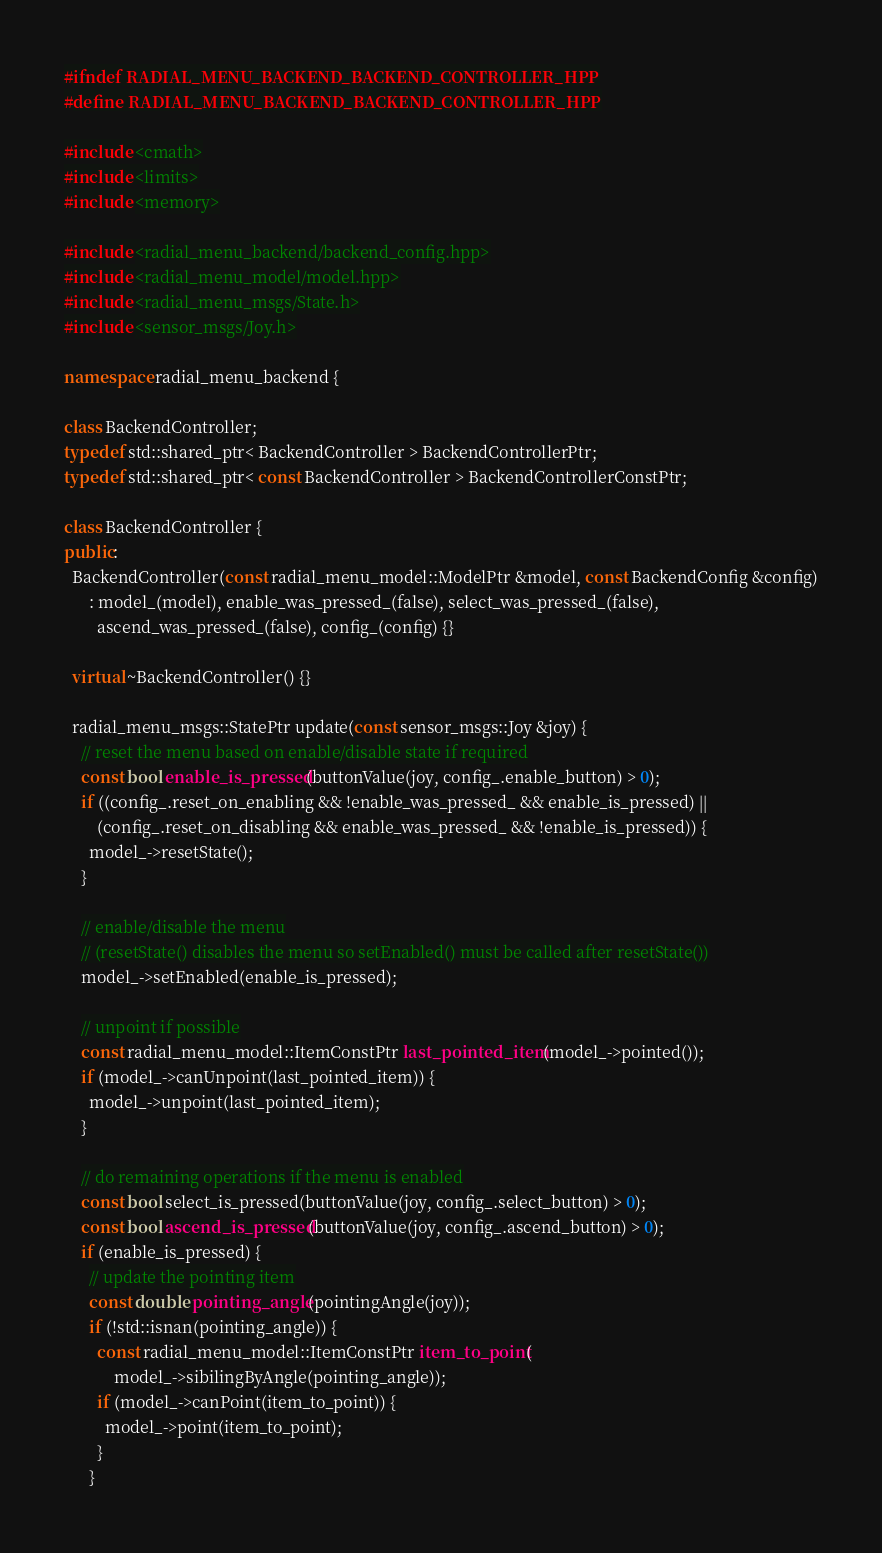Convert code to text. <code><loc_0><loc_0><loc_500><loc_500><_C++_>#ifndef RADIAL_MENU_BACKEND_BACKEND_CONTROLLER_HPP
#define RADIAL_MENU_BACKEND_BACKEND_CONTROLLER_HPP

#include <cmath>
#include <limits>
#include <memory>

#include <radial_menu_backend/backend_config.hpp>
#include <radial_menu_model/model.hpp>
#include <radial_menu_msgs/State.h>
#include <sensor_msgs/Joy.h>

namespace radial_menu_backend {

class BackendController;
typedef std::shared_ptr< BackendController > BackendControllerPtr;
typedef std::shared_ptr< const BackendController > BackendControllerConstPtr;

class BackendController {
public:
  BackendController(const radial_menu_model::ModelPtr &model, const BackendConfig &config)
      : model_(model), enable_was_pressed_(false), select_was_pressed_(false),
        ascend_was_pressed_(false), config_(config) {}

  virtual ~BackendController() {}

  radial_menu_msgs::StatePtr update(const sensor_msgs::Joy &joy) {
    // reset the menu based on enable/disable state if required
    const bool enable_is_pressed(buttonValue(joy, config_.enable_button) > 0);
    if ((config_.reset_on_enabling && !enable_was_pressed_ && enable_is_pressed) ||
        (config_.reset_on_disabling && enable_was_pressed_ && !enable_is_pressed)) {
      model_->resetState();
    }

    // enable/disable the menu
    // (resetState() disables the menu so setEnabled() must be called after resetState())
    model_->setEnabled(enable_is_pressed);

    // unpoint if possible
    const radial_menu_model::ItemConstPtr last_pointed_item(model_->pointed());
    if (model_->canUnpoint(last_pointed_item)) {
      model_->unpoint(last_pointed_item);
    }

    // do remaining operations if the menu is enabled
    const bool select_is_pressed(buttonValue(joy, config_.select_button) > 0);
    const bool ascend_is_pressed(buttonValue(joy, config_.ascend_button) > 0);
    if (enable_is_pressed) {
      // update the pointing item
      const double pointing_angle(pointingAngle(joy));
      if (!std::isnan(pointing_angle)) {
        const radial_menu_model::ItemConstPtr item_to_point(
            model_->sibilingByAngle(pointing_angle));
        if (model_->canPoint(item_to_point)) {
          model_->point(item_to_point);
        }
      }
</code> 